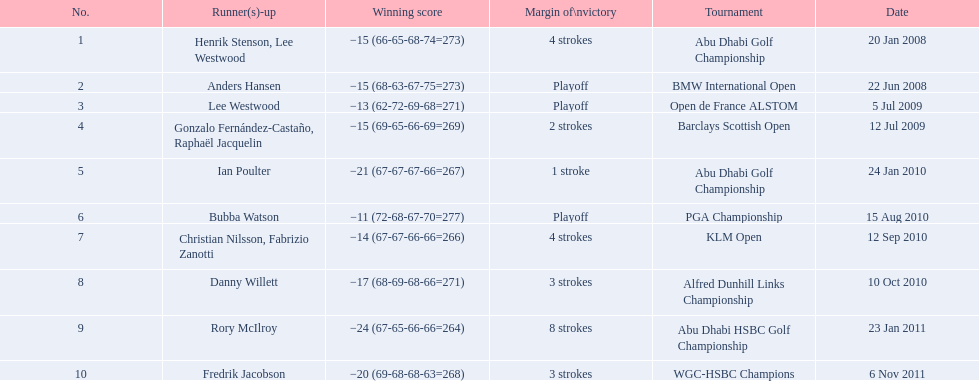How many strokes were in the klm open by martin kaymer? 4 strokes. How many strokes were in the abu dhabi golf championship? 4 strokes. How many more strokes were there in the klm than the barclays open? 2 strokes. 